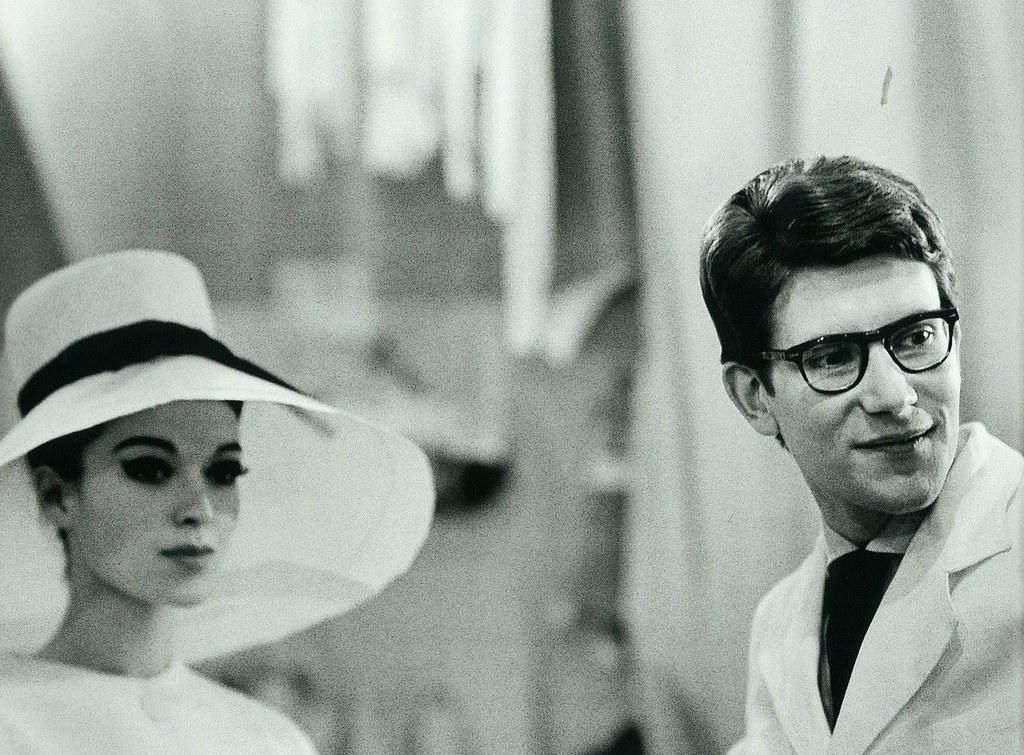What is the color scheme of the image? The image is black and white. What are the two main subjects in the image? There is a man and a woman in the image. What type of leaf is causing trouble for the man and woman in the image? There is no leaf present in the image, nor is there any indication of trouble involving a leaf. What type of soap is the man and woman using in the image? There is no soap present in the image, nor is there any indication of the man and woman using soap. 